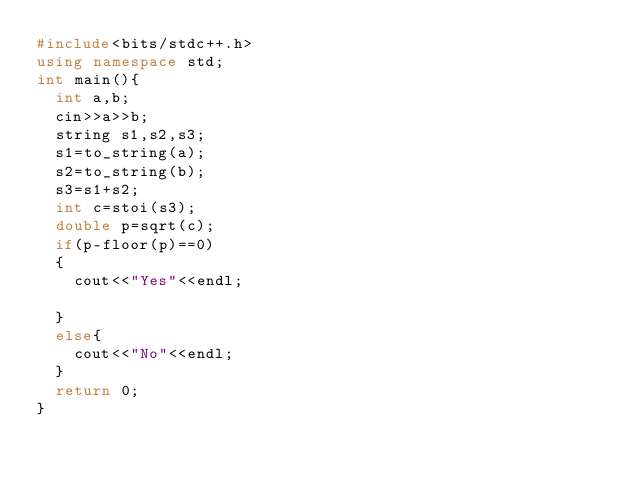<code> <loc_0><loc_0><loc_500><loc_500><_C++_>#include<bits/stdc++.h>
using namespace std;
int main(){
  int a,b;
  cin>>a>>b;
  string s1,s2,s3;
  s1=to_string(a);
  s2=to_string(b);
  s3=s1+s2;
  int c=stoi(s3);
  double p=sqrt(c);
  if(p-floor(p)==0)
  {
    cout<<"Yes"<<endl;
    
  }
  else{
    cout<<"No"<<endl;
  }
  return 0;
}</code> 